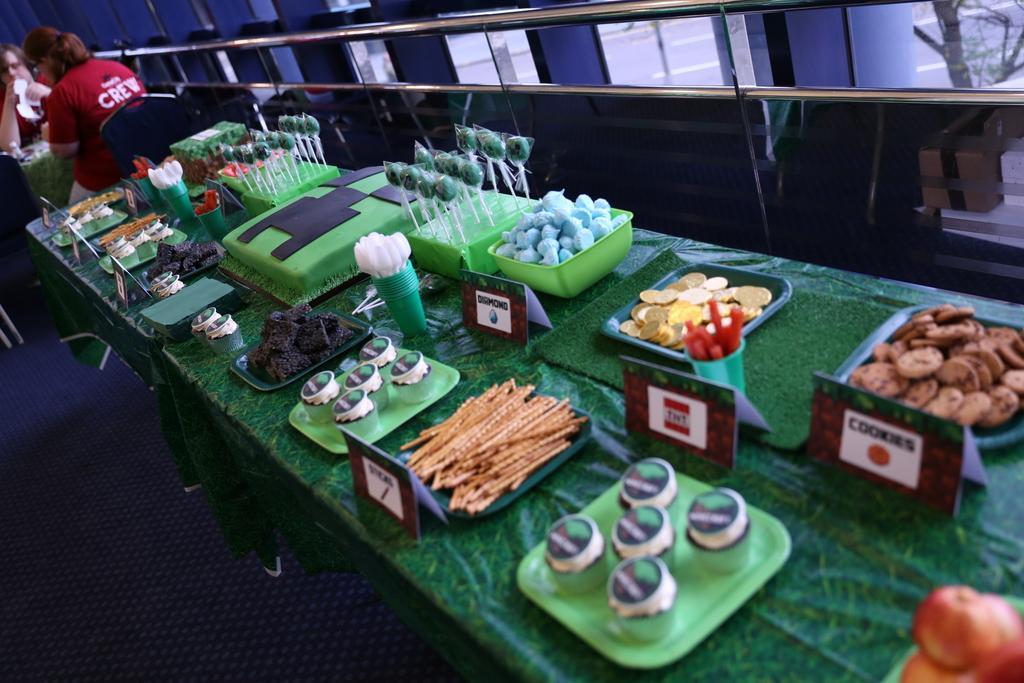Can you describe this image briefly? In the image there are cupcakes,chips,cookies and many food items on plates and there are lollipops in trays along with spoons in a glass, all are on a table, this seems to be clicked inside restaurant, on the left side corner there are two people sitting on either side of table, in the front there is fence. 